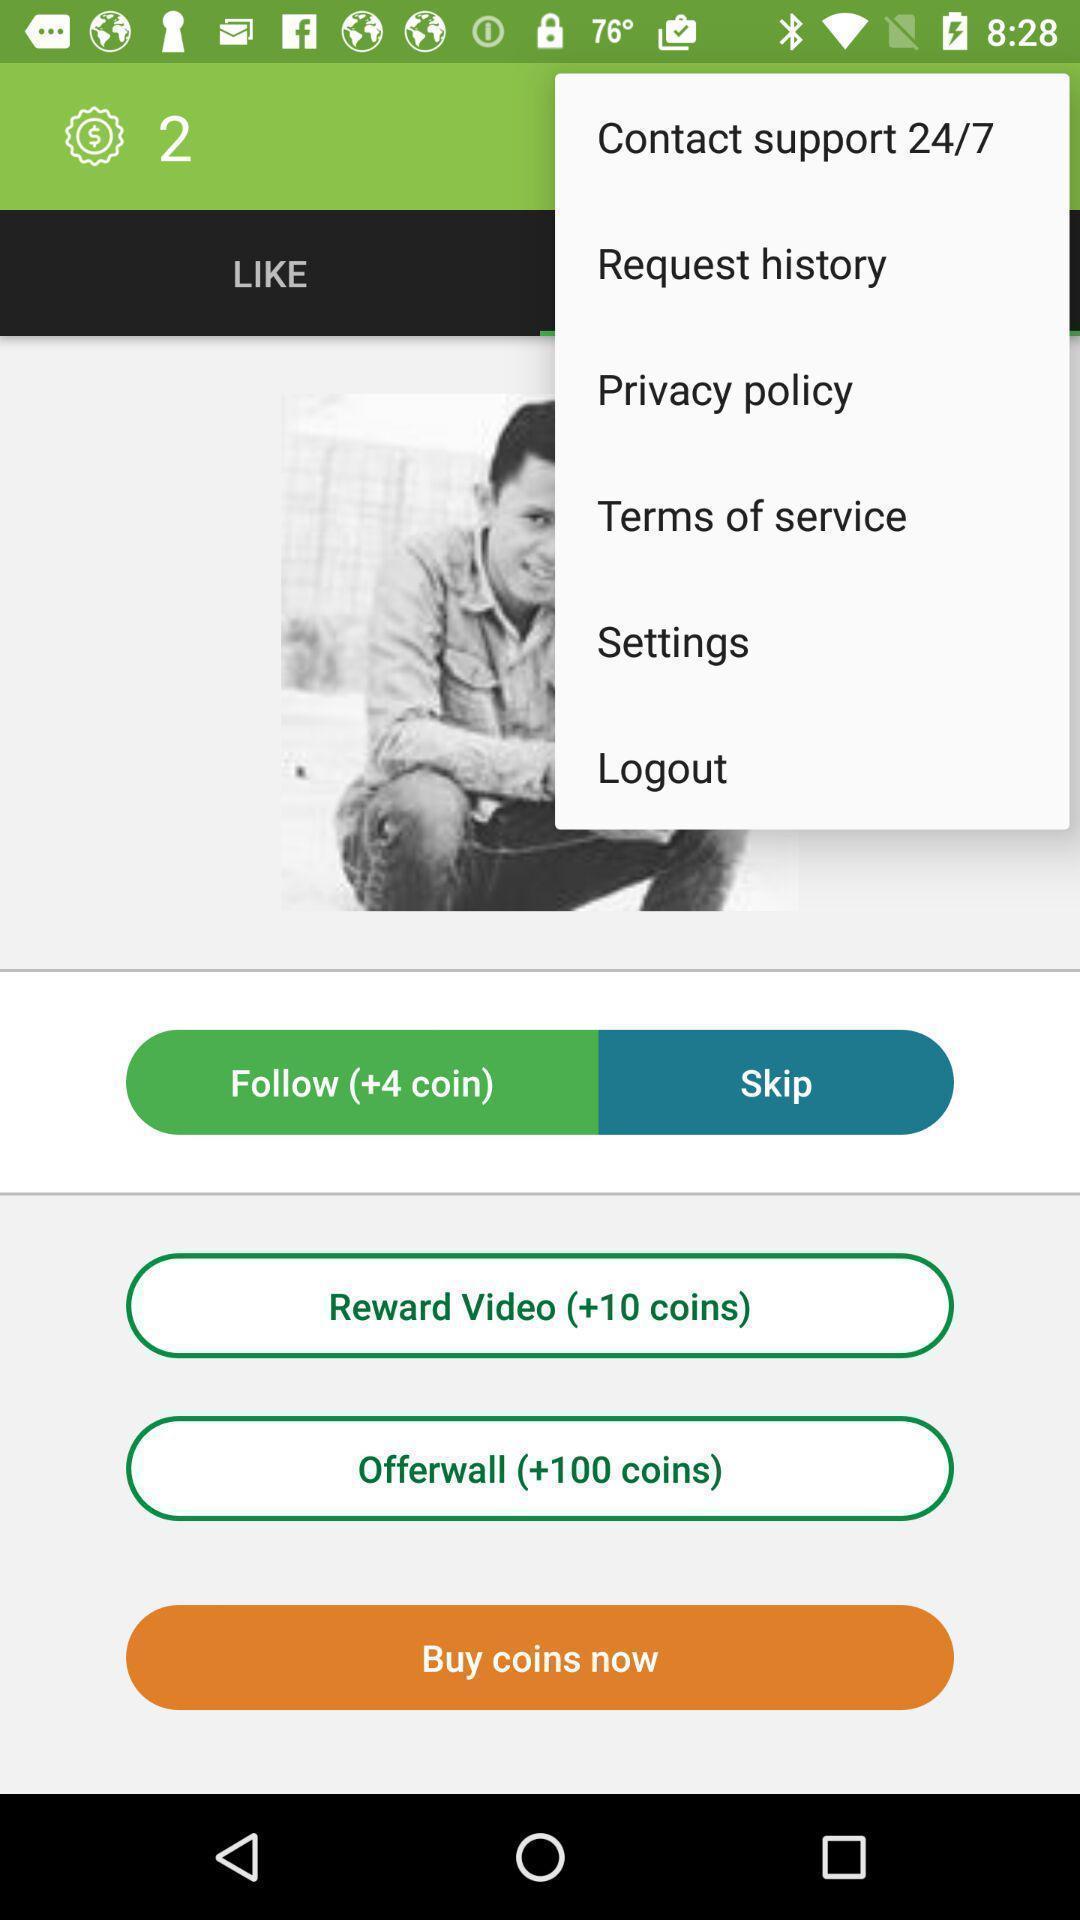What details can you identify in this image? Screen displays a list of contact support. 